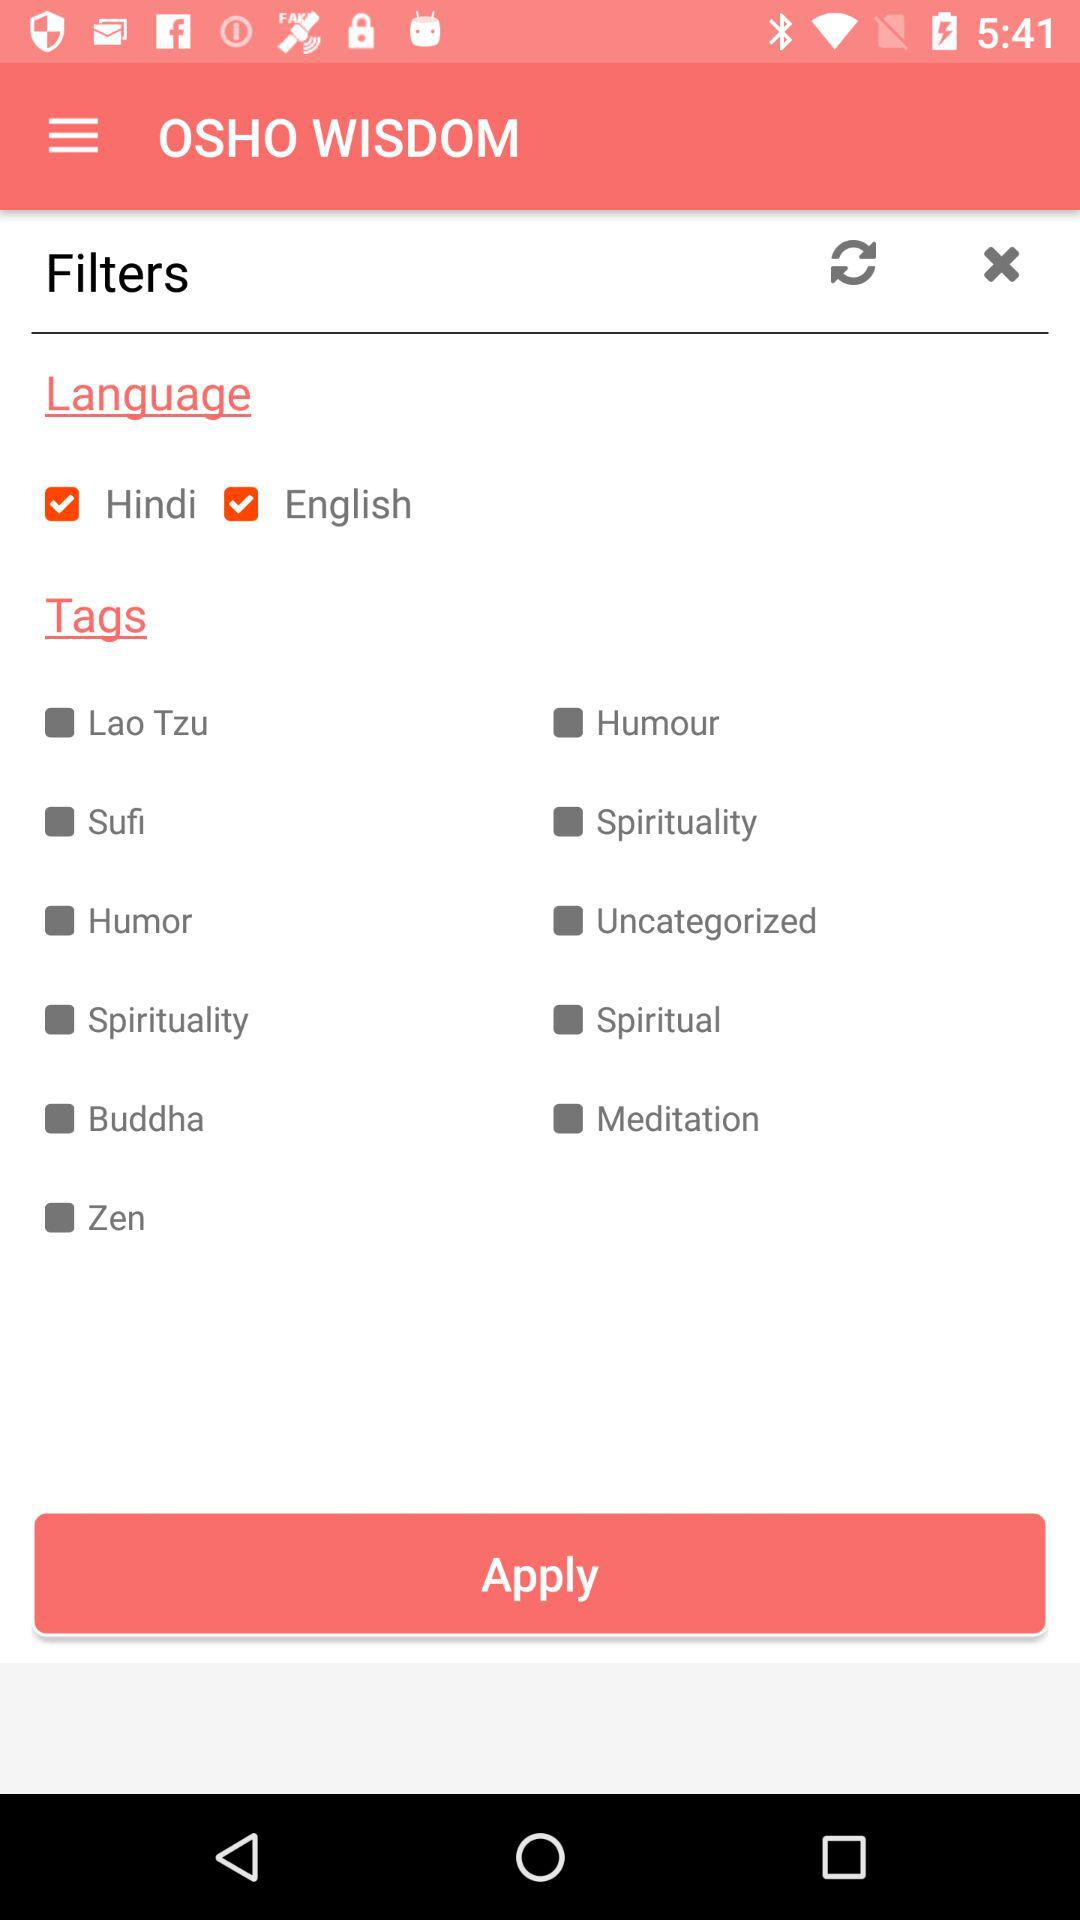What is the name of the application? The name of the application is "OSHO WISDOM". 